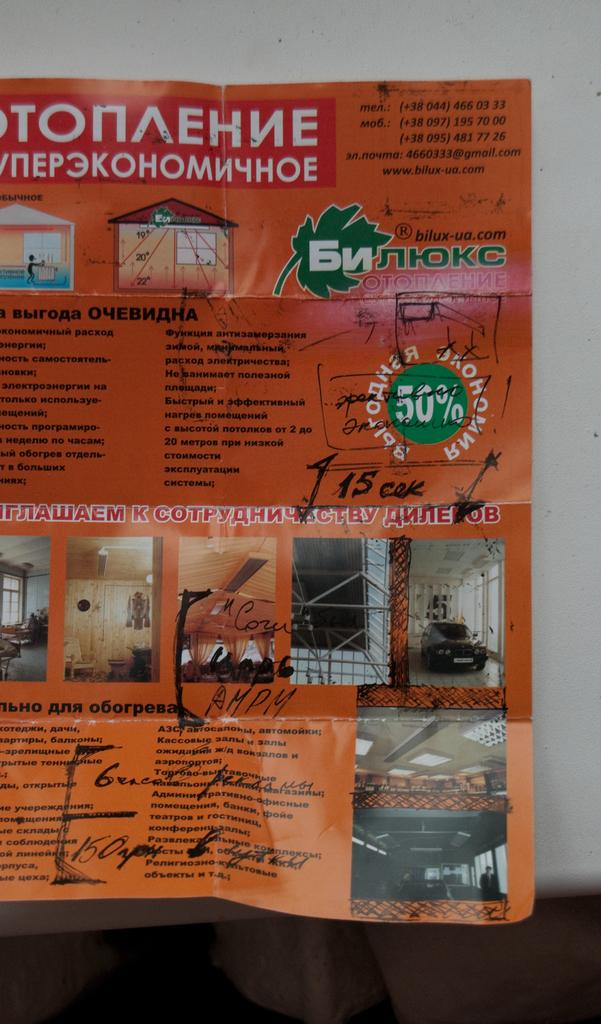What is the main object in the image? There is a pamphlet in the image. What can be found on the pamphlet? The pamphlet contains images and text. What hobbies are being distributed in the building shown in the image? There is no reference to hobbies, distribution, or a building in the image; it only features a pamphlet with images and text. 